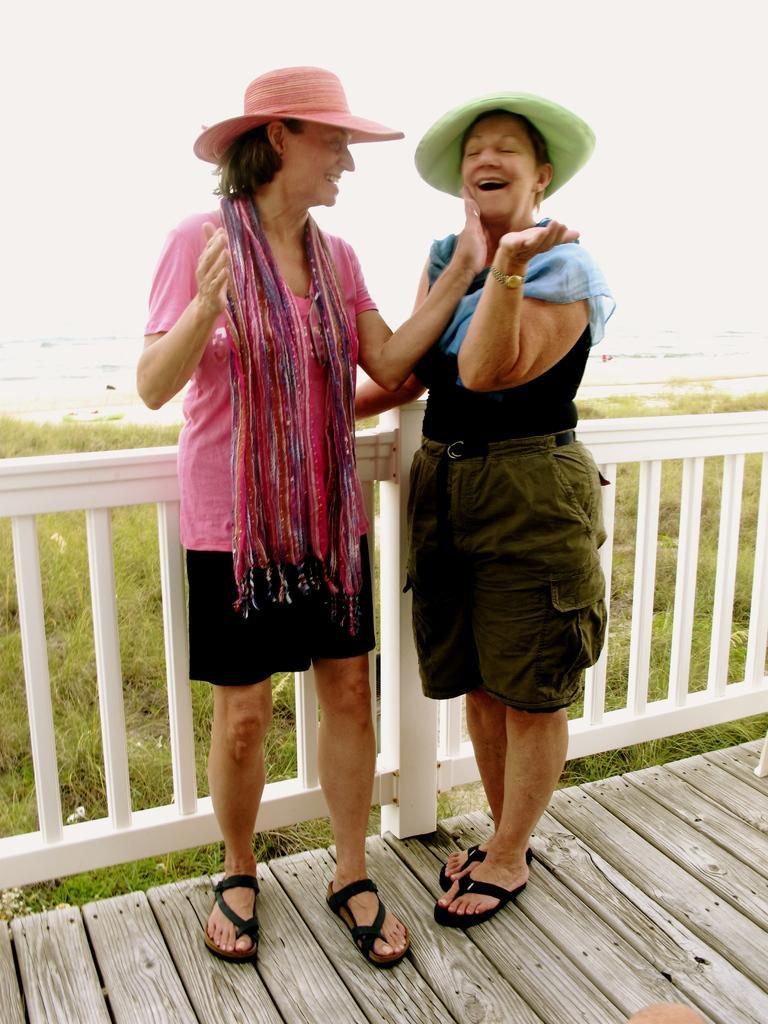Can you describe this image briefly? In the center of the image we can see two persons are standing on the wooden object. And we can see they are smiling and they are wearing hats. At the bottom right of the image, we can see some object. In the background, we can see the sky, grass and a fence. 